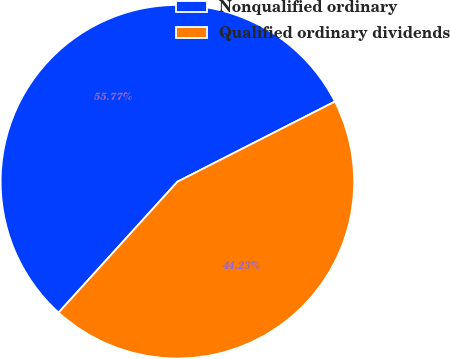<chart> <loc_0><loc_0><loc_500><loc_500><pie_chart><fcel>Nonqualified ordinary<fcel>Qualified ordinary dividends<nl><fcel>55.77%<fcel>44.23%<nl></chart> 